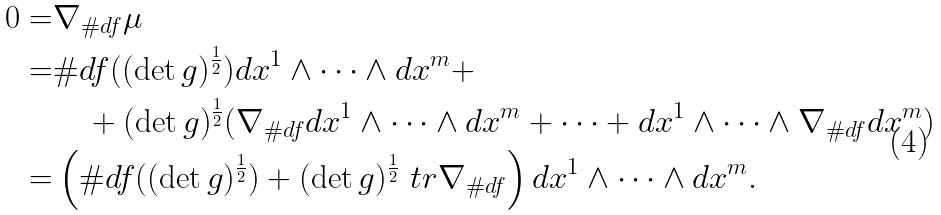<formula> <loc_0><loc_0><loc_500><loc_500>0 = & \nabla _ { \# d f } \mu \\ = & \# d f ( ( \det g ) ^ { \frac { 1 } { 2 } } ) d x ^ { 1 } \wedge \cdots \wedge d x ^ { m } + \\ & \quad + ( \det g ) ^ { \frac { 1 } { 2 } } ( \nabla _ { \# d f } d x ^ { 1 } \wedge \cdots \wedge d x ^ { m } + \cdots + d x ^ { 1 } \wedge \cdots \wedge \nabla _ { \# d f } d x ^ { m } ) \\ = & \left ( \# d f ( ( \det g ) ^ { \frac { 1 } { 2 } } ) + ( \det g ) ^ { \frac { 1 } { 2 } } \ t r \nabla _ { \# d f } \right ) d x ^ { 1 } \wedge \cdots \wedge d x ^ { m } .</formula> 